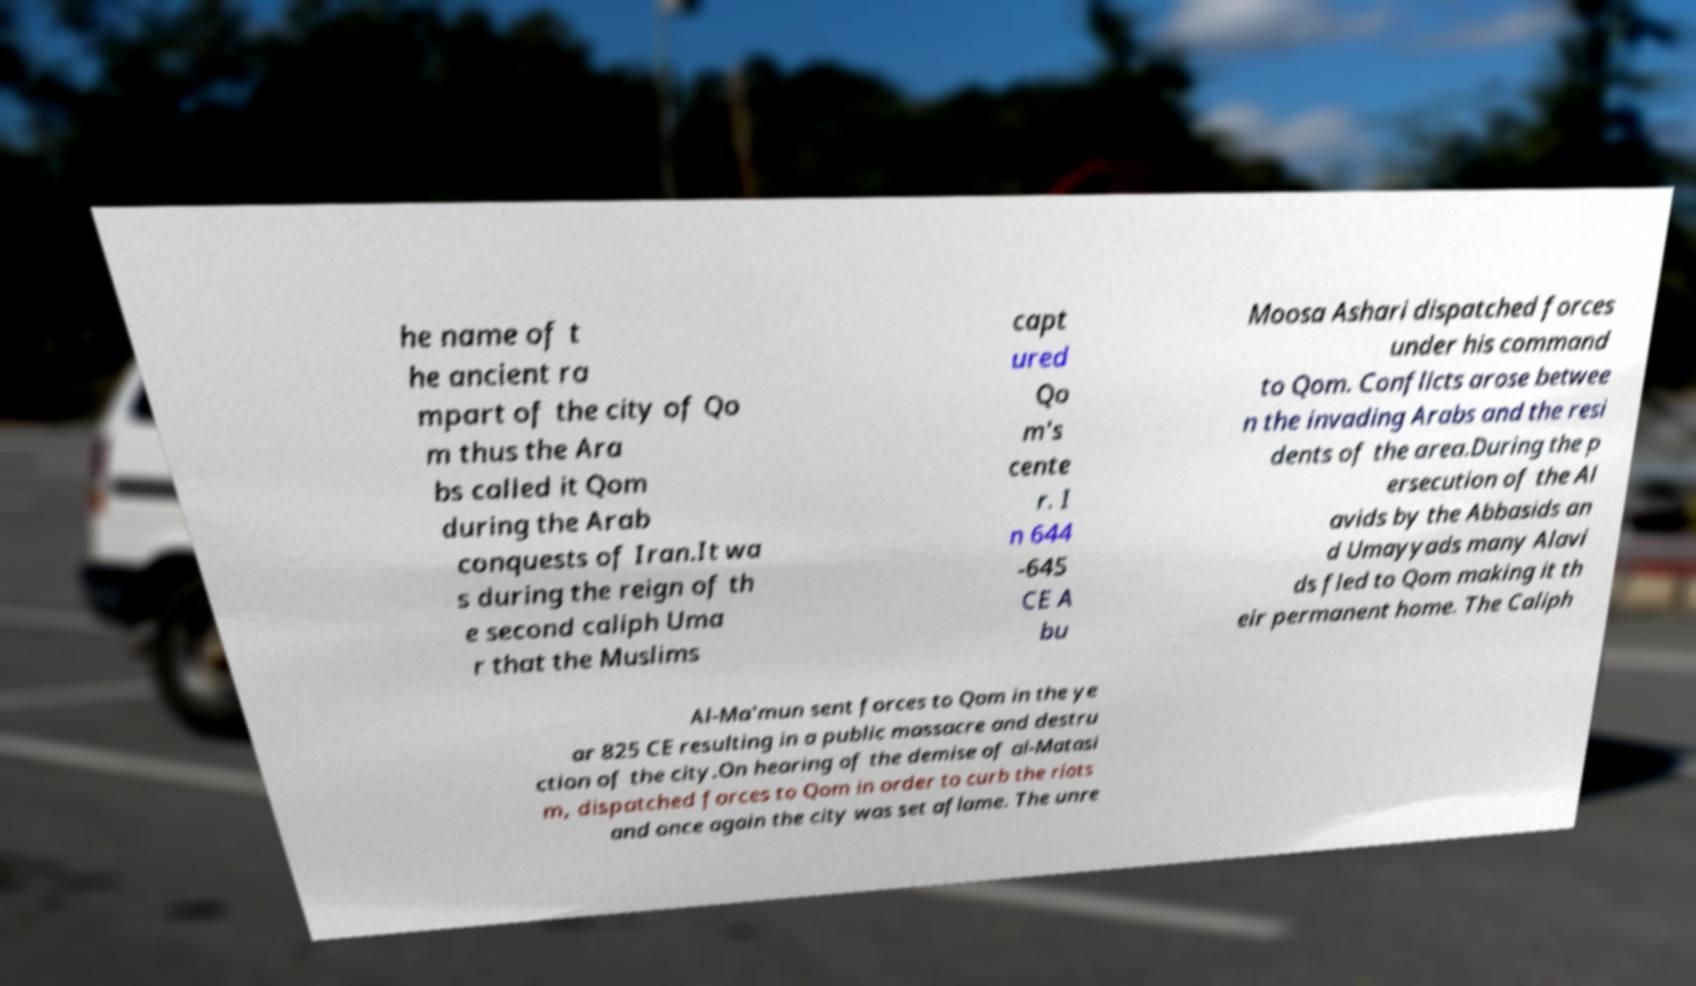Can you read and provide the text displayed in the image?This photo seems to have some interesting text. Can you extract and type it out for me? he name of t he ancient ra mpart of the city of Qo m thus the Ara bs called it Qom during the Arab conquests of Iran.It wa s during the reign of th e second caliph Uma r that the Muslims capt ured Qo m's cente r. I n 644 -645 CE A bu Moosa Ashari dispatched forces under his command to Qom. Conflicts arose betwee n the invading Arabs and the resi dents of the area.During the p ersecution of the Al avids by the Abbasids an d Umayyads many Alavi ds fled to Qom making it th eir permanent home. The Caliph Al-Ma'mun sent forces to Qom in the ye ar 825 CE resulting in a public massacre and destru ction of the city.On hearing of the demise of al-Matasi m, dispatched forces to Qom in order to curb the riots and once again the city was set aflame. The unre 